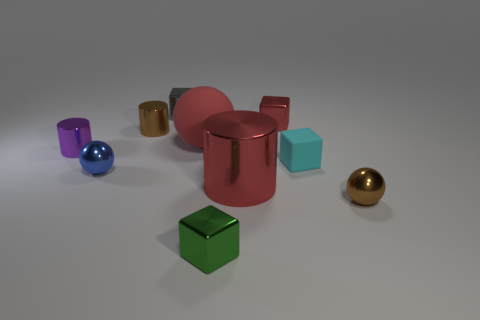Subtract all tiny metallic balls. How many balls are left? 1 Subtract all yellow blocks. How many cyan balls are left? 0 Subtract all gray blocks. How many blocks are left? 3 Subtract all cylinders. How many objects are left? 7 Subtract 1 cubes. How many cubes are left? 3 Subtract all red cylinders. Subtract all red blocks. How many cylinders are left? 2 Subtract all yellow shiny cubes. Subtract all large red metal things. How many objects are left? 9 Add 6 small rubber blocks. How many small rubber blocks are left? 7 Add 6 tiny yellow matte balls. How many tiny yellow matte balls exist? 6 Subtract 0 purple spheres. How many objects are left? 10 